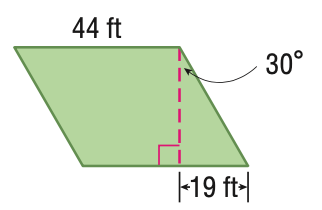Question: Find the area of the parallelogram. Round to the nearest tenth if necessary.
Choices:
A. 164
B. 362.0
C. 724.0
D. 1448.0
Answer with the letter. Answer: D Question: Find the perimeter of the parallelogram. Round to the nearest tenth if necessary.
Choices:
A. 82
B. 164
C. 836
D. 1448
Answer with the letter. Answer: B 